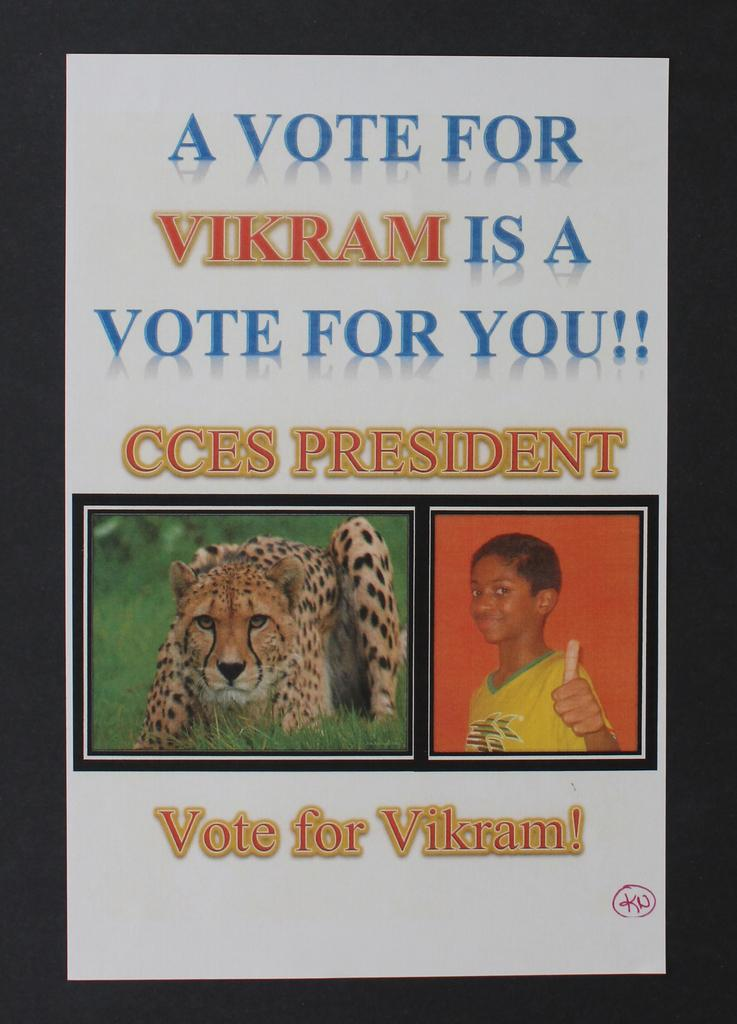What is present on the white paper in the image? There are two pictures on a white paper. What else can be seen on the white paper besides the pictures? There is text written on the paper. How many children are visible in the image? There are no children present in the image; it only features two pictures on a white paper with text. 